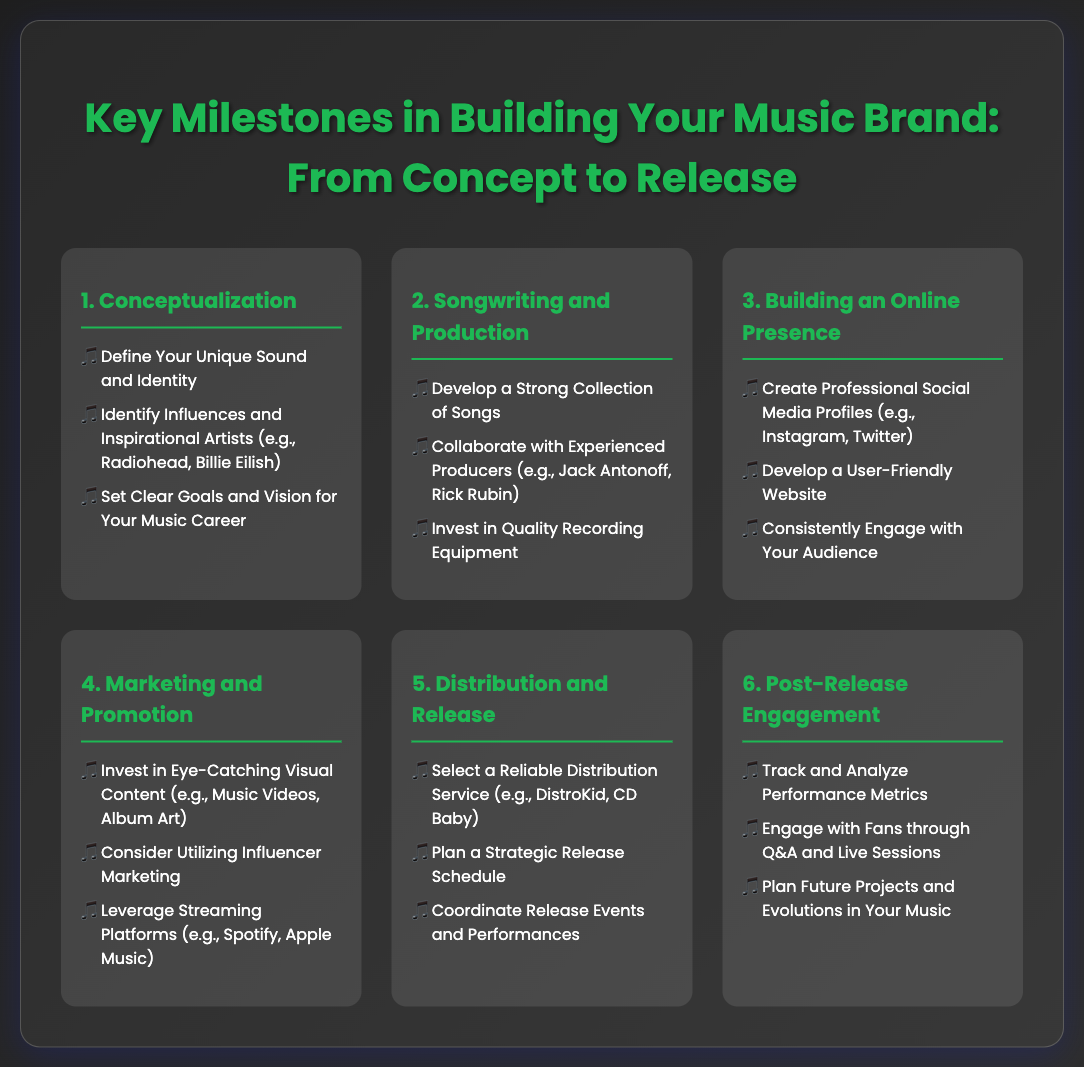What is the first milestone in building your music brand? The first milestone listed in the document is Conceptualization.
Answer: Conceptualization Which influential artists are mentioned as examples? The document lists Radiohead and Billie Eilish as examples of influential artists.
Answer: Radiohead, Billie Eilish What is one suggestion for building an online presence? The document suggests creating professional social media profiles as a key step in building an online presence.
Answer: Create Professional Social Media Profiles What is the fifth milestone related to? The fifth milestone discusses Distribution and Release in the music brand-building process.
Answer: Distribution and Release Which service is mentioned for music distribution? The document mentions DistroKid and CD Baby as reliable distribution services.
Answer: DistroKid, CD Baby What is an important activity in the Post-Release Engagement phase? Engaging with fans through Q&A and live sessions is highlighted as an important activity after the release.
Answer: Engage with Fans through Q&A and Live Sessions How many key milestones are there in total? The document outlines a total of six key milestones in building a music brand.
Answer: Six 